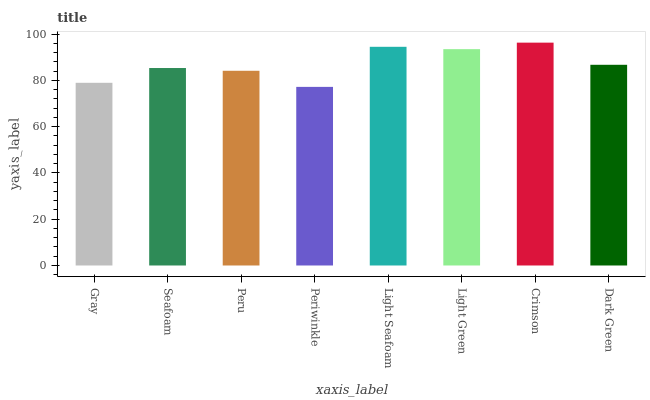Is Periwinkle the minimum?
Answer yes or no. Yes. Is Crimson the maximum?
Answer yes or no. Yes. Is Seafoam the minimum?
Answer yes or no. No. Is Seafoam the maximum?
Answer yes or no. No. Is Seafoam greater than Gray?
Answer yes or no. Yes. Is Gray less than Seafoam?
Answer yes or no. Yes. Is Gray greater than Seafoam?
Answer yes or no. No. Is Seafoam less than Gray?
Answer yes or no. No. Is Dark Green the high median?
Answer yes or no. Yes. Is Seafoam the low median?
Answer yes or no. Yes. Is Crimson the high median?
Answer yes or no. No. Is Gray the low median?
Answer yes or no. No. 